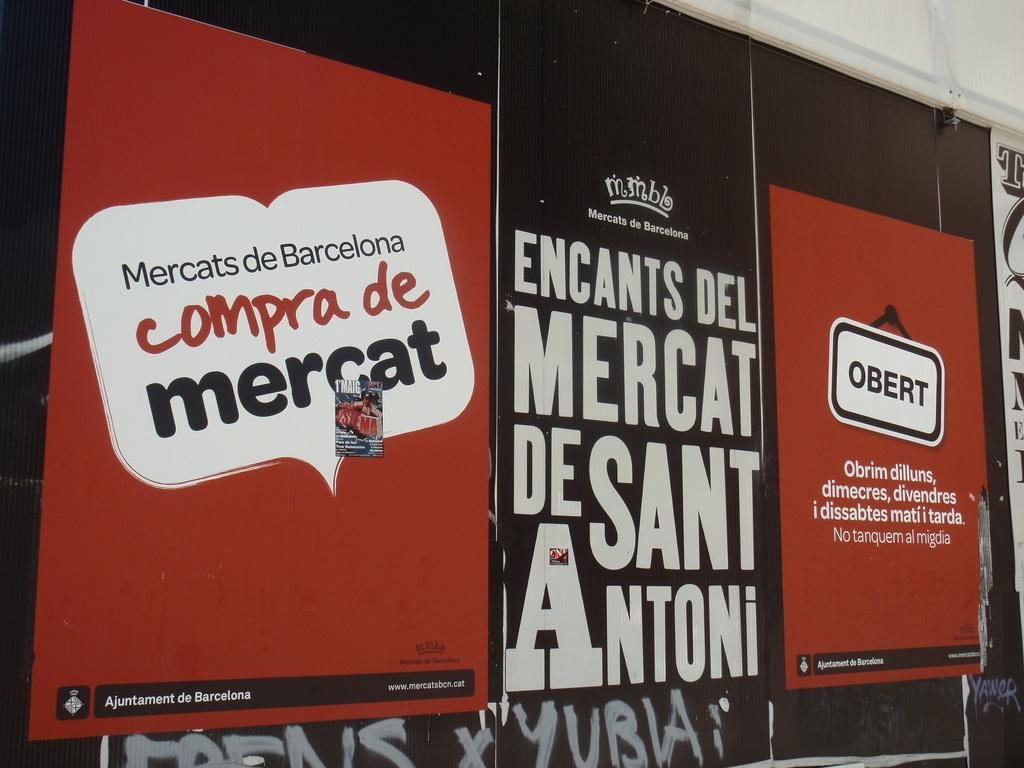What is present on the wall in the image? There are red and brown color advertisements and white color words on the wall in the image. Can you describe the advertisements on the wall? The advertisements on the wall are in red and brown colors. What color are the words on the wall? The words on the wall are white in color. How many spiders can be seen crawling on the wall in the image? There are no spiders visible on the wall in the image. What type of medical facility is depicted in the image? There is no hospital or medical facility depicted in the image; it only features a wall with advertisements and words. 